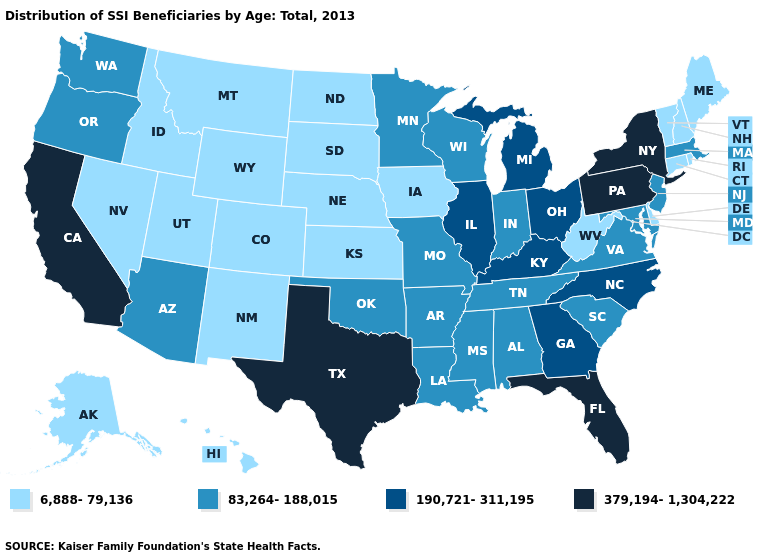Name the states that have a value in the range 379,194-1,304,222?
Answer briefly. California, Florida, New York, Pennsylvania, Texas. Does the map have missing data?
Short answer required. No. Name the states that have a value in the range 379,194-1,304,222?
Keep it brief. California, Florida, New York, Pennsylvania, Texas. What is the highest value in the USA?
Answer briefly. 379,194-1,304,222. Does the first symbol in the legend represent the smallest category?
Quick response, please. Yes. Which states have the lowest value in the USA?
Concise answer only. Alaska, Colorado, Connecticut, Delaware, Hawaii, Idaho, Iowa, Kansas, Maine, Montana, Nebraska, Nevada, New Hampshire, New Mexico, North Dakota, Rhode Island, South Dakota, Utah, Vermont, West Virginia, Wyoming. Does Colorado have the same value as Wyoming?
Short answer required. Yes. Among the states that border Utah , does Arizona have the lowest value?
Quick response, please. No. Does Pennsylvania have the highest value in the USA?
Answer briefly. Yes. Name the states that have a value in the range 379,194-1,304,222?
Keep it brief. California, Florida, New York, Pennsylvania, Texas. What is the lowest value in the West?
Write a very short answer. 6,888-79,136. Among the states that border Louisiana , does Texas have the lowest value?
Keep it brief. No. Name the states that have a value in the range 379,194-1,304,222?
Answer briefly. California, Florida, New York, Pennsylvania, Texas. How many symbols are there in the legend?
Quick response, please. 4. Name the states that have a value in the range 379,194-1,304,222?
Short answer required. California, Florida, New York, Pennsylvania, Texas. 